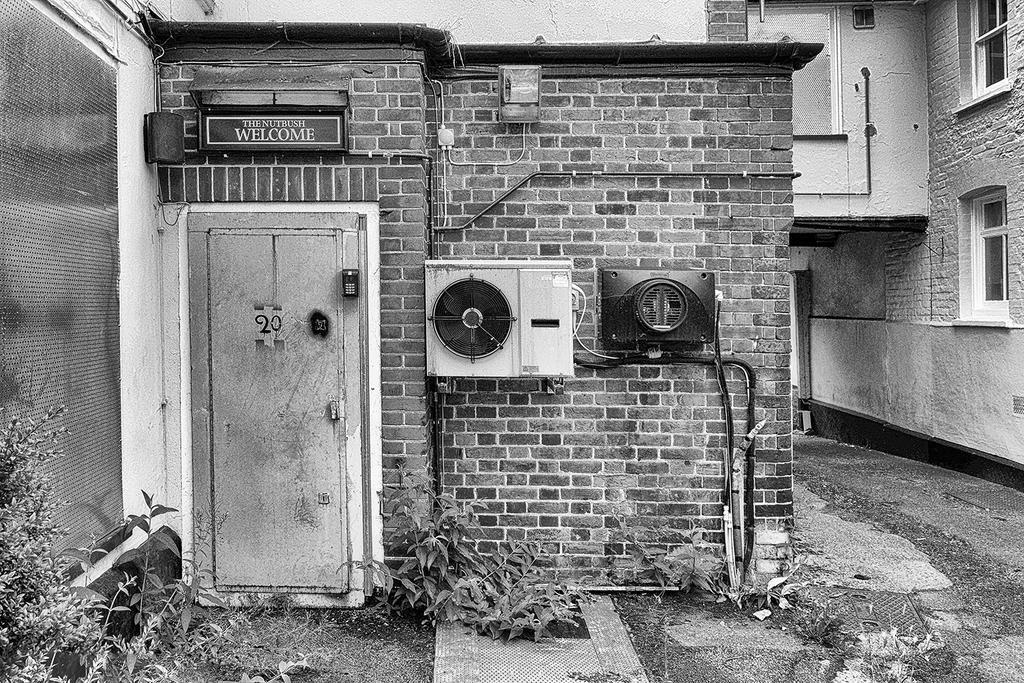Could you give a brief overview of what you see in this image? In this image, we can see few houses, brick wall, some machines, door, name board, pipes, windows. At the bottom, we can see a walkway, few plants. 